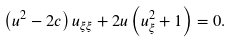<formula> <loc_0><loc_0><loc_500><loc_500>\left ( u ^ { 2 } - 2 c \right ) u _ { \xi \xi } + 2 u \left ( u _ { \xi } ^ { 2 } + 1 \right ) = 0 .</formula> 